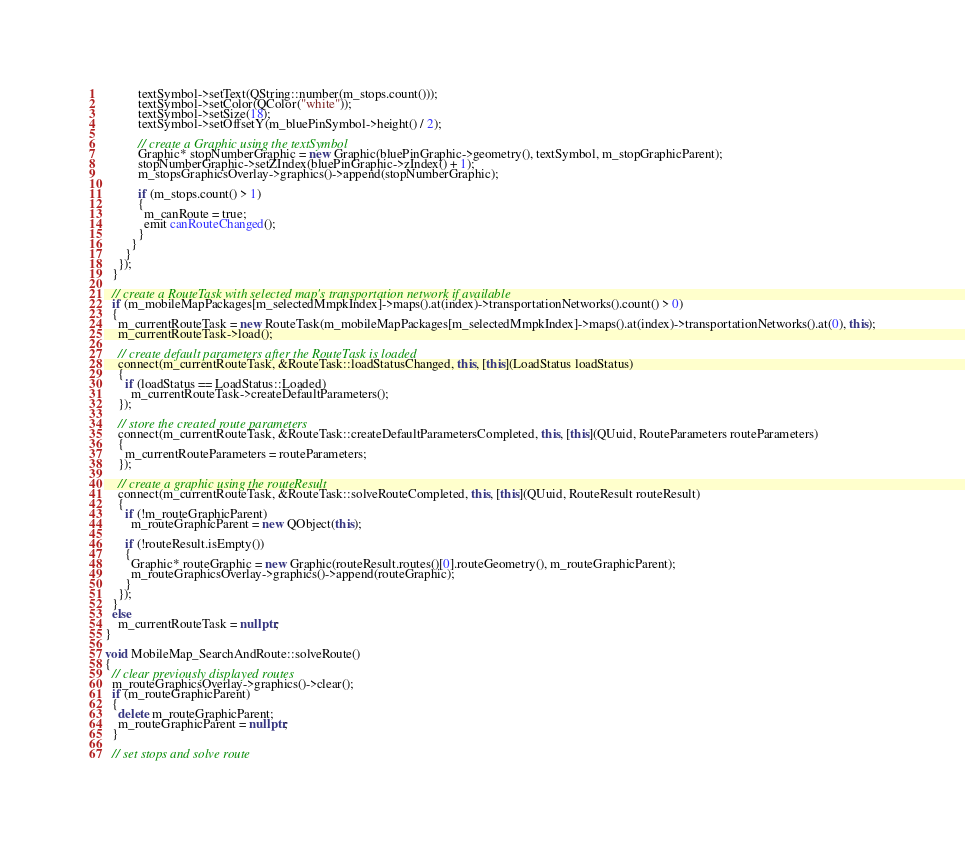Convert code to text. <code><loc_0><loc_0><loc_500><loc_500><_C++_>          textSymbol->setText(QString::number(m_stops.count()));
          textSymbol->setColor(QColor("white"));
          textSymbol->setSize(18);
          textSymbol->setOffsetY(m_bluePinSymbol->height() / 2);

          // create a Graphic using the textSymbol
          Graphic* stopNumberGraphic = new Graphic(bluePinGraphic->geometry(), textSymbol, m_stopGraphicParent);
          stopNumberGraphic->setZIndex(bluePinGraphic->zIndex() + 1);
          m_stopsGraphicsOverlay->graphics()->append(stopNumberGraphic);

          if (m_stops.count() > 1)
          {
            m_canRoute = true;
            emit canRouteChanged();
          }
        }
      }
    });
  }

  // create a RouteTask with selected map's transportation network if available
  if (m_mobileMapPackages[m_selectedMmpkIndex]->maps().at(index)->transportationNetworks().count() > 0)
  {
    m_currentRouteTask = new RouteTask(m_mobileMapPackages[m_selectedMmpkIndex]->maps().at(index)->transportationNetworks().at(0), this);
    m_currentRouteTask->load();

    // create default parameters after the RouteTask is loaded
    connect(m_currentRouteTask, &RouteTask::loadStatusChanged, this, [this](LoadStatus loadStatus)
    {
      if (loadStatus == LoadStatus::Loaded)
        m_currentRouteTask->createDefaultParameters();
    });

    // store the created route parameters
    connect(m_currentRouteTask, &RouteTask::createDefaultParametersCompleted, this, [this](QUuid, RouteParameters routeParameters)
    {
      m_currentRouteParameters = routeParameters;
    });

    // create a graphic using the routeResult
    connect(m_currentRouteTask, &RouteTask::solveRouteCompleted, this, [this](QUuid, RouteResult routeResult)
    {
      if (!m_routeGraphicParent)
        m_routeGraphicParent = new QObject(this);

      if (!routeResult.isEmpty())
      {
        Graphic* routeGraphic = new Graphic(routeResult.routes()[0].routeGeometry(), m_routeGraphicParent);
        m_routeGraphicsOverlay->graphics()->append(routeGraphic);
      }
    });
  }
  else
    m_currentRouteTask = nullptr;
}

void MobileMap_SearchAndRoute::solveRoute()
{
  // clear previously displayed routes
  m_routeGraphicsOverlay->graphics()->clear();
  if (m_routeGraphicParent)
  {
    delete m_routeGraphicParent;
    m_routeGraphicParent = nullptr;
  }

  // set stops and solve route</code> 